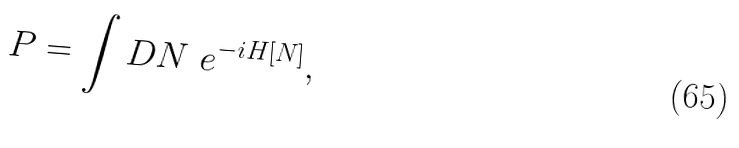<formula> <loc_0><loc_0><loc_500><loc_500>P = \int D N \ e ^ { - i H [ N ] } ,</formula> 